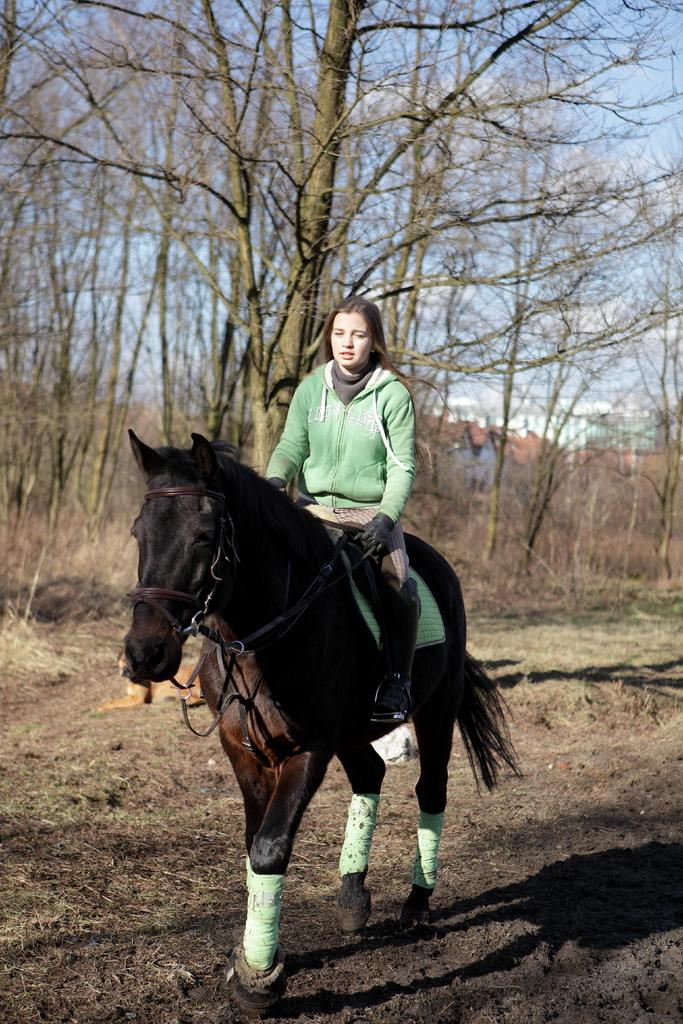Who is the main subject in the image? There is a girl in the image. What is the girl doing in the image? The girl is sitting on a horse. Where are the horse and girl located in the image? The horse and girl are on a path. What can be seen in the background of the image? There are trees and the sky visible in the background of the image. How many wheels can be seen on the horse in the image? Horses do not have wheels; they are living creatures with legs. --- Facts: 1. There is a car in the image. 2. The car is red. 3. The car has four wheels. 4. There is a road in the image. 5. The sky is visible in the image. Absurd Topics: bird, ocean, mountain Conversation: What is the main subject in the image? There is a car in the image. What color is the car? The car is red. How many wheels does the car have? The car has four wheels. Where is the car located in the image? The car is on a road. What else can be seen in the image besides the car? The sky is visible in the image. Reasoning: Let's think step by step in order to produce the conversation. We start by identifying the main subject in the image, which is the car. Then, we describe the color and number of wheels of the car. Next, we mention the location of the car, which is on a road. Finally, we describe the background of the image, which includes the sky. Absurd Question/Answer: Can you see any mountains in the image? There are no mountains visible in the image; it features a red car on a road with the sky in the background. 